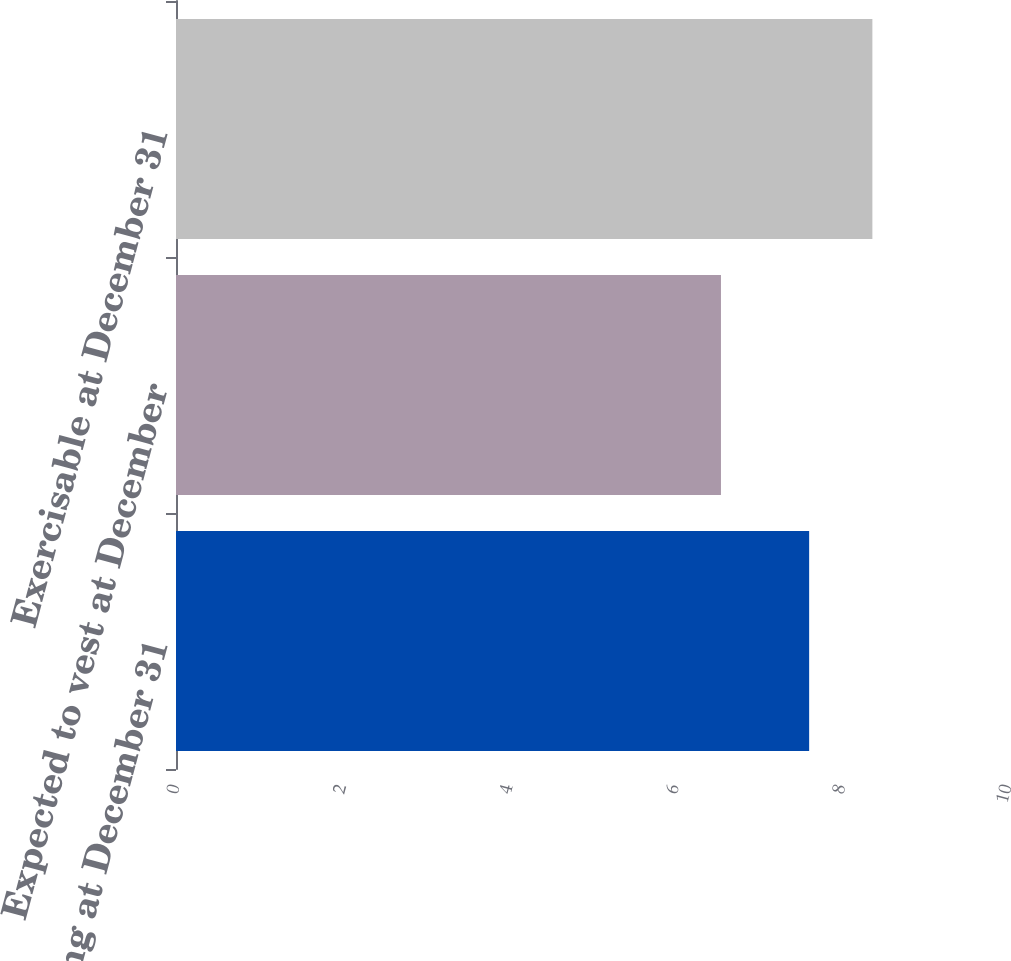Convert chart. <chart><loc_0><loc_0><loc_500><loc_500><bar_chart><fcel>Outstanding at December 31<fcel>Expected to vest at December<fcel>Exercisable at December 31<nl><fcel>7.61<fcel>6.55<fcel>8.37<nl></chart> 